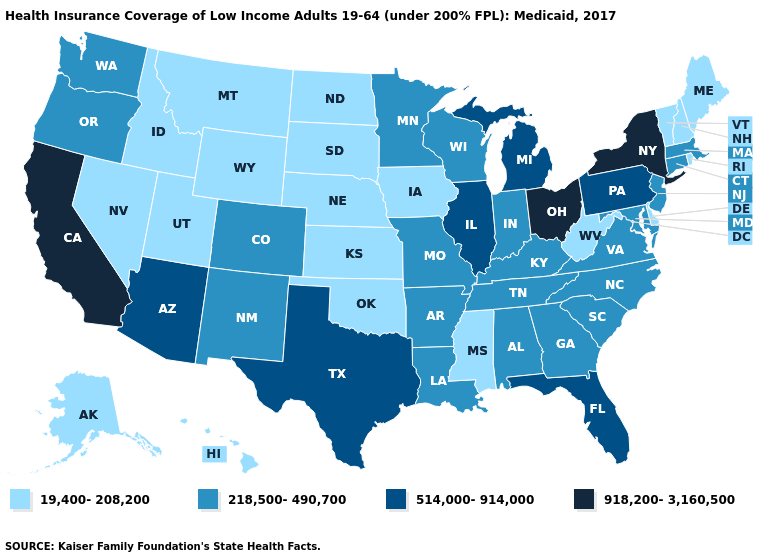Does Kentucky have a lower value than Washington?
Answer briefly. No. Name the states that have a value in the range 19,400-208,200?
Concise answer only. Alaska, Delaware, Hawaii, Idaho, Iowa, Kansas, Maine, Mississippi, Montana, Nebraska, Nevada, New Hampshire, North Dakota, Oklahoma, Rhode Island, South Dakota, Utah, Vermont, West Virginia, Wyoming. Which states have the lowest value in the West?
Write a very short answer. Alaska, Hawaii, Idaho, Montana, Nevada, Utah, Wyoming. What is the value of Pennsylvania?
Concise answer only. 514,000-914,000. Does New York have the highest value in the USA?
Keep it brief. Yes. Does the first symbol in the legend represent the smallest category?
Quick response, please. Yes. What is the highest value in states that border North Carolina?
Concise answer only. 218,500-490,700. What is the lowest value in states that border Colorado?
Short answer required. 19,400-208,200. What is the highest value in the USA?
Answer briefly. 918,200-3,160,500. What is the value of Tennessee?
Answer briefly. 218,500-490,700. Does Colorado have the lowest value in the West?
Be succinct. No. How many symbols are there in the legend?
Quick response, please. 4. What is the value of Tennessee?
Keep it brief. 218,500-490,700. 